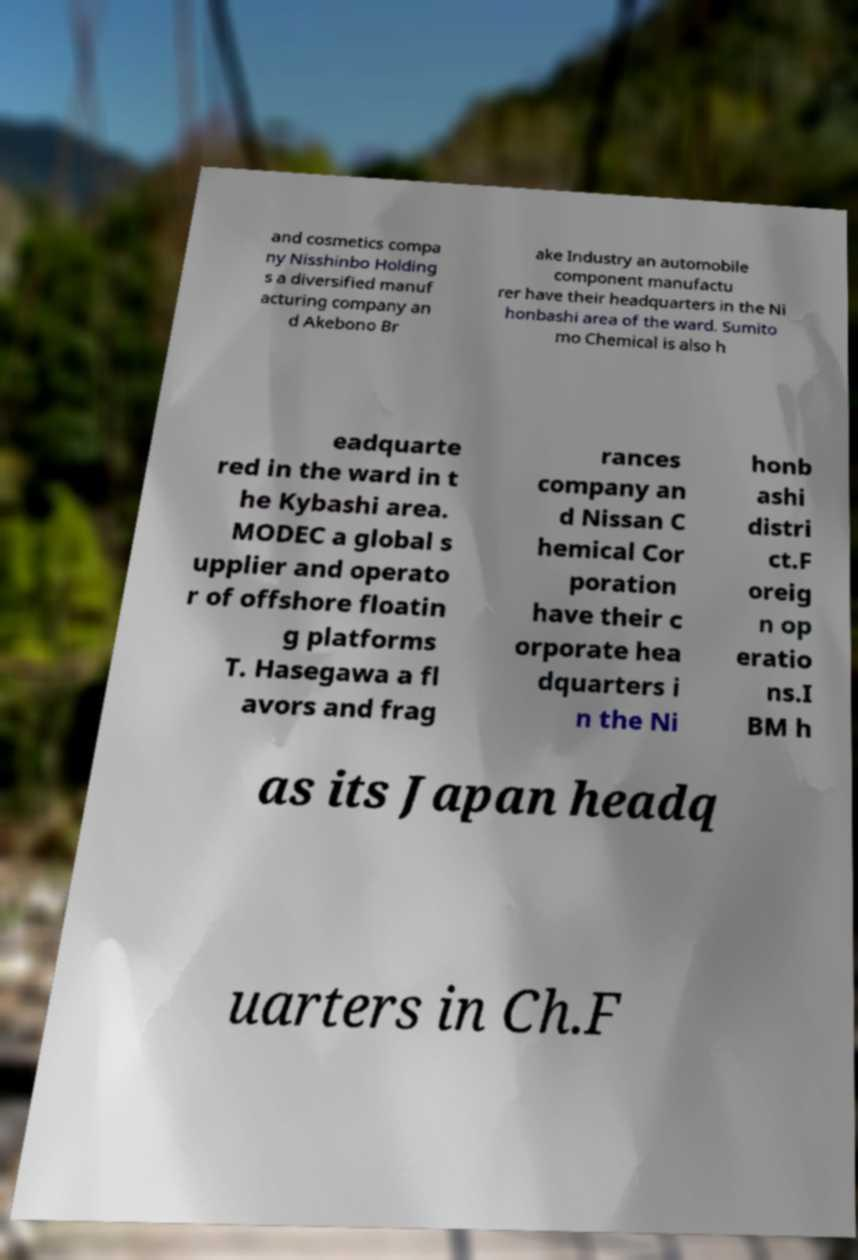Could you extract and type out the text from this image? and cosmetics compa ny Nisshinbo Holding s a diversified manuf acturing company an d Akebono Br ake Industry an automobile component manufactu rer have their headquarters in the Ni honbashi area of the ward. Sumito mo Chemical is also h eadquarte red in the ward in t he Kybashi area. MODEC a global s upplier and operato r of offshore floatin g platforms T. Hasegawa a fl avors and frag rances company an d Nissan C hemical Cor poration have their c orporate hea dquarters i n the Ni honb ashi distri ct.F oreig n op eratio ns.I BM h as its Japan headq uarters in Ch.F 